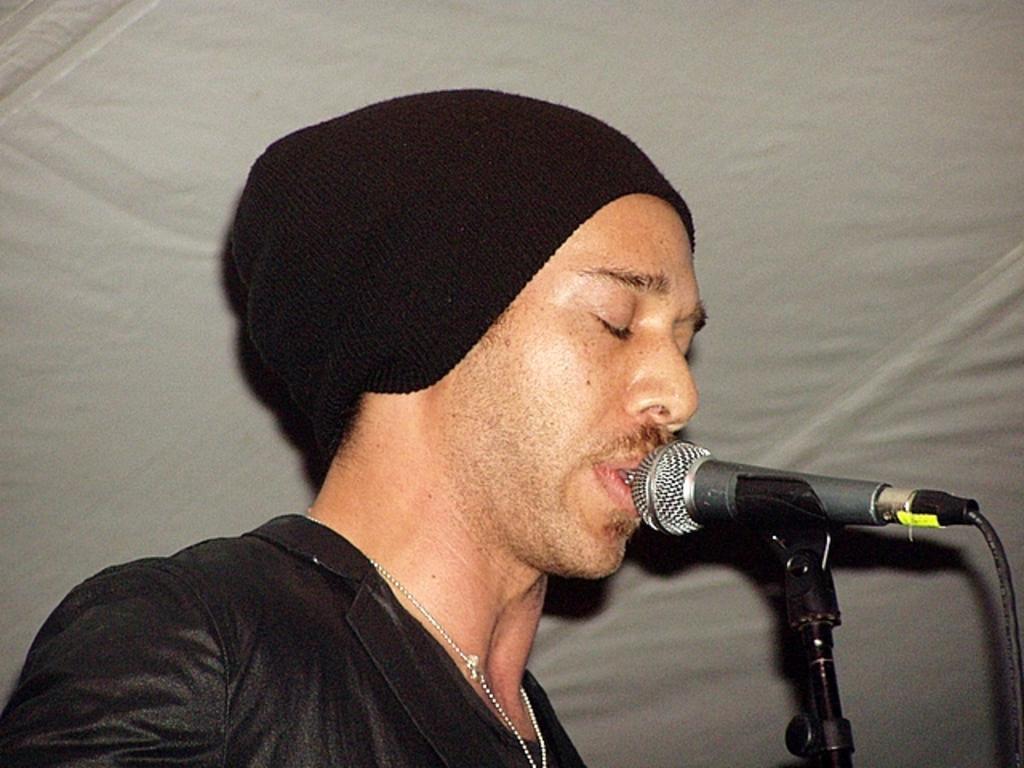How would you summarize this image in a sentence or two? In the middle of the image a man is standing. Behind him there is cloth. In the bottom right side of the image there is a microphone. 